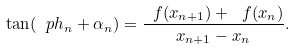<formula> <loc_0><loc_0><loc_500><loc_500>\tan ( \ p h _ { n } + \alpha _ { n } ) = \frac { \ f ( x _ { n + 1 } ) + \ f ( x _ { n } ) } { x _ { n + 1 } - x _ { n } } .</formula> 